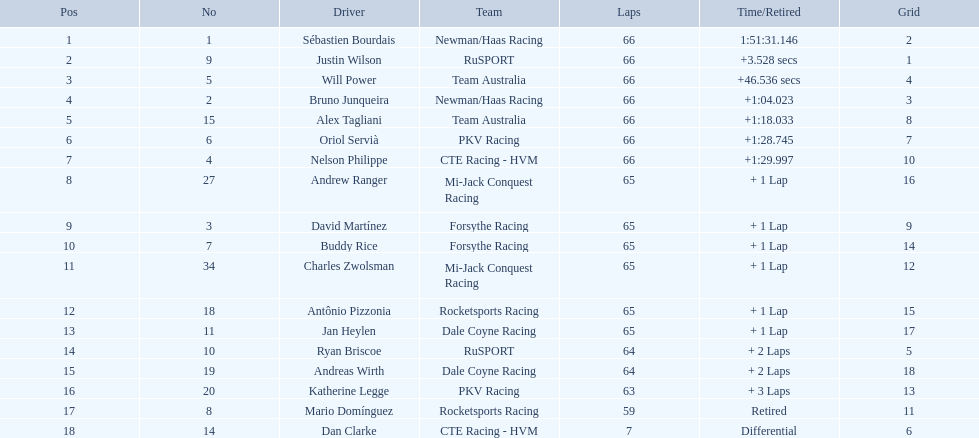Who are the drivers? Sébastien Bourdais, Justin Wilson, Will Power, Bruno Junqueira, Alex Tagliani, Oriol Servià, Nelson Philippe, Andrew Ranger, David Martínez, Buddy Rice, Charles Zwolsman, Antônio Pizzonia, Jan Heylen, Ryan Briscoe, Andreas Wirth, Katherine Legge, Mario Domínguez, Dan Clarke. What are their numbers? 1, 9, 5, 2, 15, 6, 4, 27, 3, 7, 34, 18, 11, 10, 19, 20, 8, 14. What are their positions? 1, 2, 3, 4, 5, 6, 7, 8, 9, 10, 11, 12, 13, 14, 15, 16, 17, 18. Which driver has the same number and position? Sébastien Bourdais. 